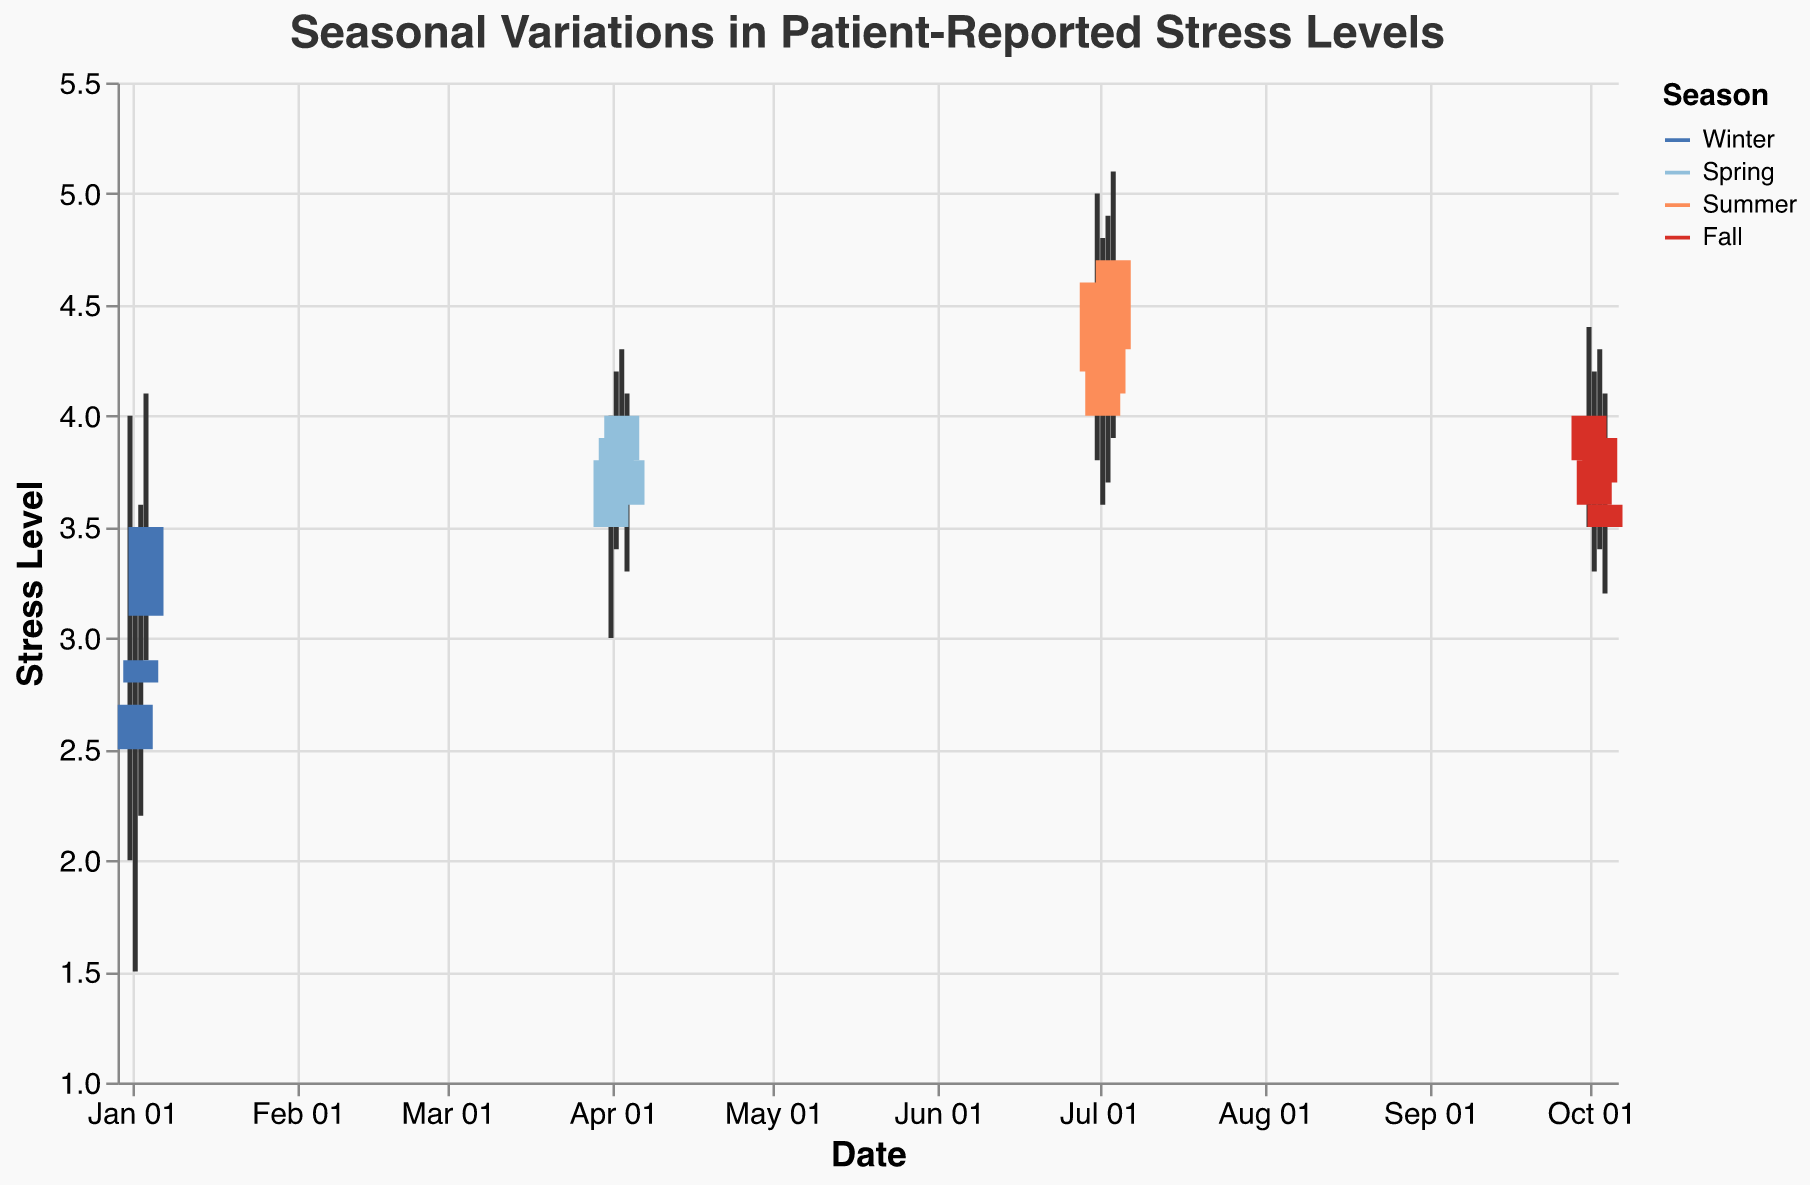What is the title of the figure? The title of the figure is usually located at the top and provides an insight into what the figure is about. In this case, the title is given as "Seasonal Variations in Patient-Reported Stress Levels".
Answer: Seasonal Variations in Patient-Reported Stress Levels What are the colors used to represent the different seasons? The colors used in the chart to represent different seasons help distinguish between them. Winter is represented by blue, Spring by light blue, Summer by orange, and Fall by red.
Answer: Blue, light blue, orange, red What period in the year had the highest reported stress levels? Observing the data points on the candlestick plot, the highest values for stress levels can be seen during Summer, where the High values are in the range of 4.8 to 5.1.
Answer: Summer Which season has the lowest minimum stress level? By comparing the Low values on the plot for each season, Winter has the lowest reported stress level with a minimum value of 1.5 on January 2, 2022.
Answer: Winter How did stress levels change from the start to the end of Winter? For Winter, compare the Open value on January 1, 2022 (3) to the Close value on January 4, 2022 (3.5). Stress levels increased from the start to the end of Winter.
Answer: Increased from 3 to 3.5 On which specific date did Summer have the highest recorded stress level? Observing the candlestick for each date in Summer, the highest recorded stress level (High) is on July 4, 2022, at a value of 5.1.
Answer: July 4, 2022 What is the average closing stress level during Fall? The Close values for Fall are 4.0, 3.8, 3.9, and 3.6. Calculating the average: (4.0 + 3.8 + 3.9 + 3.6) / 4 = 3.825.
Answer: 3.825 How does Spring's average high stress level compare to Winter's average high stress level? Calculate the high values for each season: Spring (4.0+4.2+4.3+4.1)/4 = 4.15, Winter (4+3.5+3.6+4.1)/4 = 3.8. Compare the averages: 4.15 is higher than 3.8.
Answer: Spring’s average is higher than Winter’s Which season had the most consistent (least variable) stress levels? Consistency can be observed via the range between High and Low values for each season. Sum these ranges: Winter (2,2,2,1.2), Spring (1,0.8,0.8,0.8), Summer (1.2,1.2,1.2,1.2), and Fall (0.9,0.9,0.9,0.9). Fall has the tightest range.
Answer: Fall 